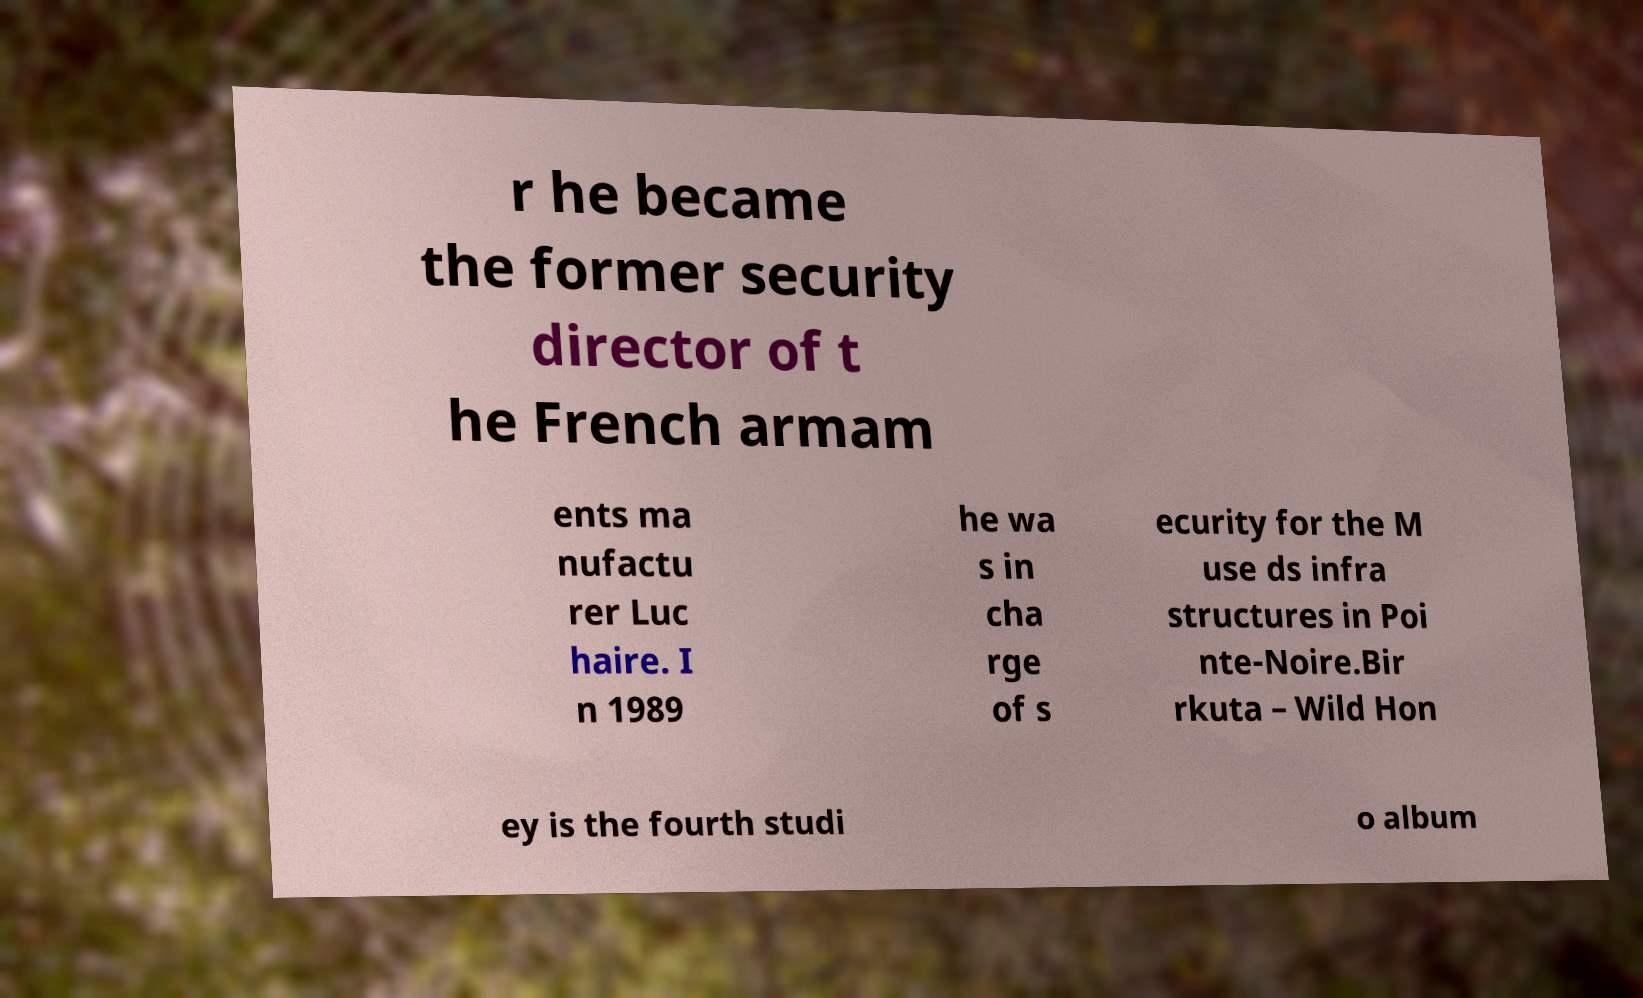Could you extract and type out the text from this image? r he became the former security director of t he French armam ents ma nufactu rer Luc haire. I n 1989 he wa s in cha rge of s ecurity for the M use ds infra structures in Poi nte-Noire.Bir rkuta – Wild Hon ey is the fourth studi o album 